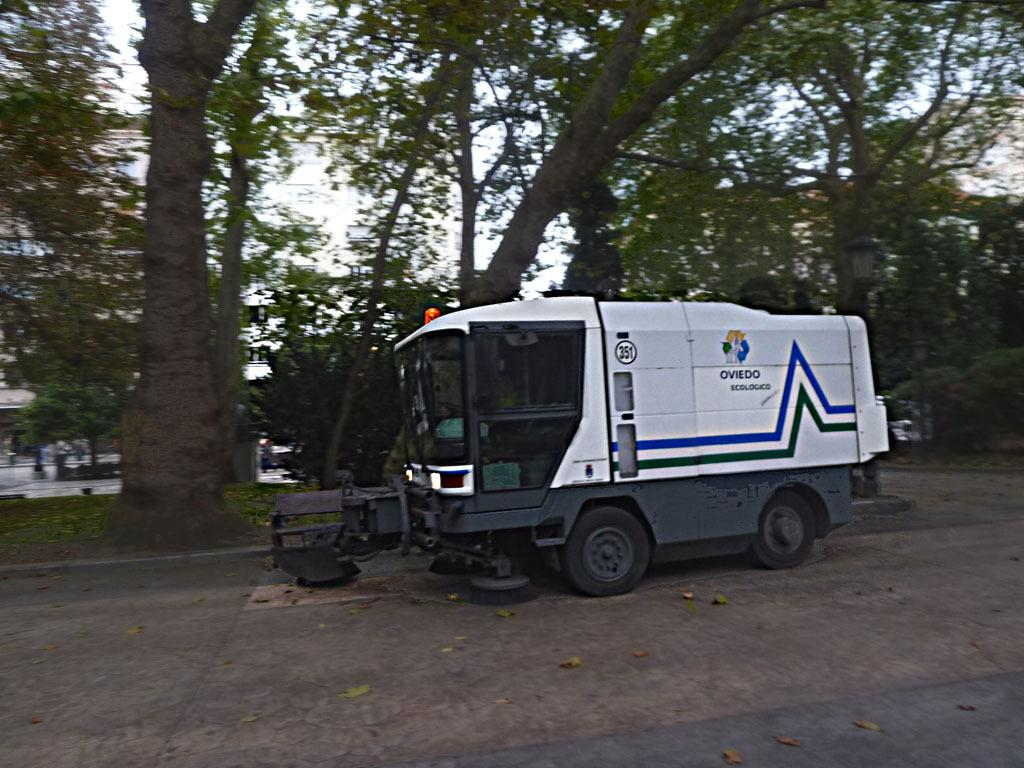What is the main subject of the image? There is a road sweeper in the image. Where is the road sweeper located? The road sweeper is on a road. What can be seen in the background of the image? There are trees in the background of the image. What type of poison is the road sweeper using to clean the road in the image? There is no mention of poison in the image, and the road sweeper is not using any poison to clean the road. 